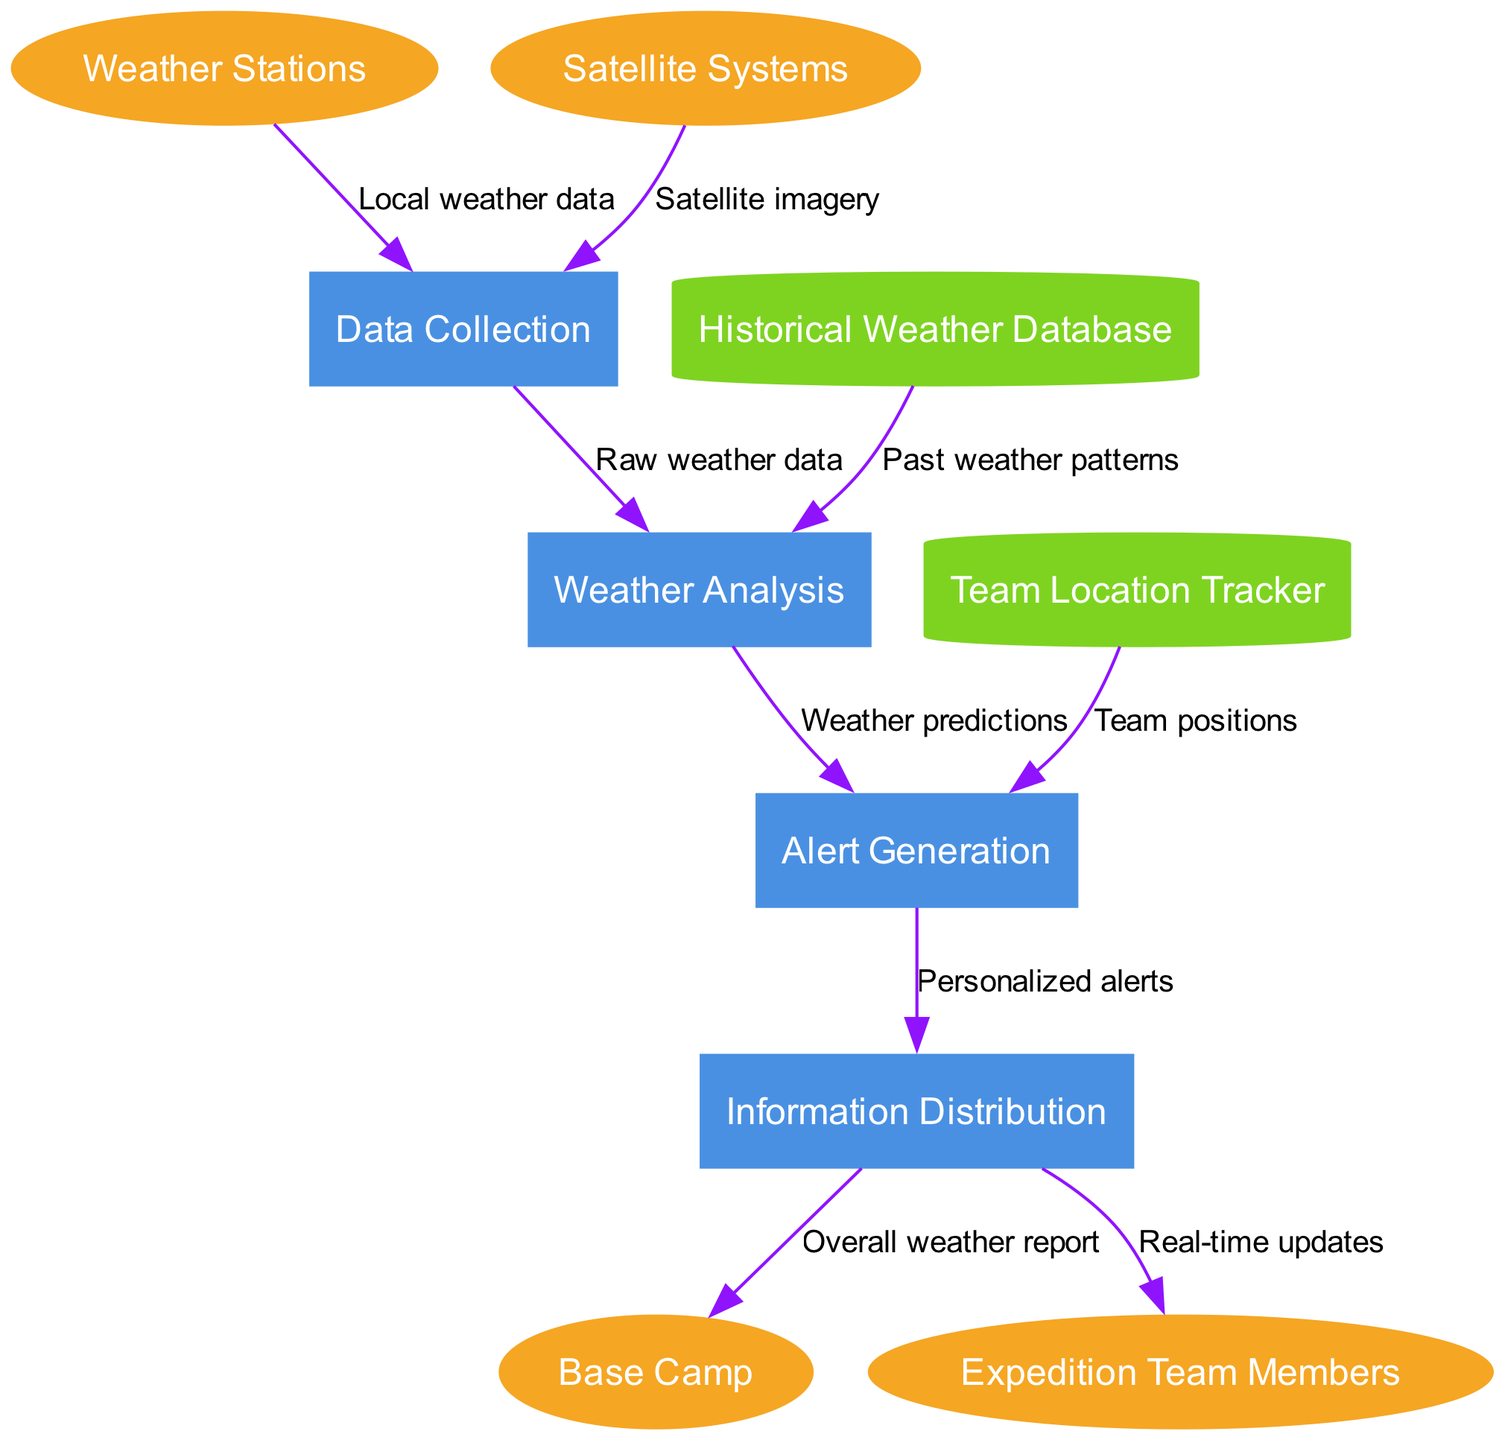What are the external entities in the diagram? The diagram identifies four external entities: Weather Stations, Satellite Systems, Base Camp, and Expedition Team Members. These entities interact with the communication network to send and receive weather-related information.
Answer: Weather Stations, Satellite Systems, Base Camp, Expedition Team Members How many processes are represented in the diagram? The diagram contains four processes, which are Data Collection, Weather Analysis, Alert Generation, and Information Distribution. Each of these processes contributes to the overall functionality of the system.
Answer: 4 Which process receives raw weather data? The raw weather data is sent from the Data Collection process to the Weather Analysis process. This indicates that the Weather Analysis uses this data to make predictions and generate alerts.
Answer: Weather Analysis What type of data store is the Historical Weather Database? The Historical Weather Database is represented as a cylinder in the diagram, which is a standard symbol for a data store in Data Flow Diagrams. It holds historical data that aids in analyzing weather patterns.
Answer: Cylinder Which external entity receives real-time updates? The real-time updates are sent from the Information Distribution process to the Expedition Team Members. This ensures that team members are informed about current weather conditions affecting their expedition.
Answer: Expedition Team Members What triggers the Alert Generation process? The Alert Generation process is triggered by two inputs: weather predictions from the Weather Analysis process and team positions from the Team Location Tracker. This dual input allows for personalized alerts based on both forecasting and team activity.
Answer: Weather predictions, Team positions How many data flows are there from the Data Collection process? There are two data flows that emerge from the Data Collection process: the first flow sends raw weather data to Weather Analysis, and the second flow receives data from Weather Stations and Satellite Systems. This indicates that Data Collection is central to gathering information before analysis.
Answer: 2 What is the purpose of the Information Distribution process? The Information Distribution process disseminates alerts generated to both the Base Camp and Expedition Team Members. Its main purpose is to ensure that critical weather information reaches all relevant parties in real time.
Answer: Disseminate alerts Which data flow provides past weather patterns to the Weather Analysis process? The Historical Weather Database sends the past weather patterns to the Weather Analysis process, enabling it to analyze trends and make more accurate predictions based on historical data.
Answer: Past weather patterns 